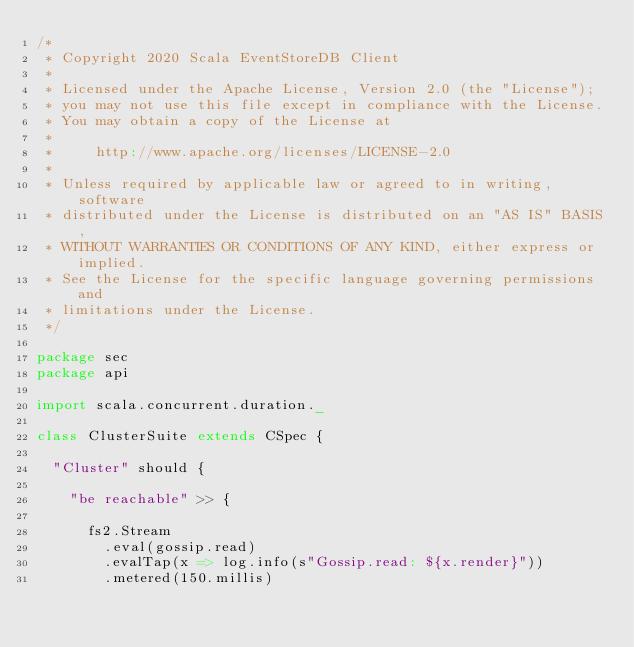Convert code to text. <code><loc_0><loc_0><loc_500><loc_500><_Scala_>/*
 * Copyright 2020 Scala EventStoreDB Client
 *
 * Licensed under the Apache License, Version 2.0 (the "License");
 * you may not use this file except in compliance with the License.
 * You may obtain a copy of the License at
 *
 *     http://www.apache.org/licenses/LICENSE-2.0
 *
 * Unless required by applicable law or agreed to in writing, software
 * distributed under the License is distributed on an "AS IS" BASIS,
 * WITHOUT WARRANTIES OR CONDITIONS OF ANY KIND, either express or implied.
 * See the License for the specific language governing permissions and
 * limitations under the License.
 */

package sec
package api

import scala.concurrent.duration._

class ClusterSuite extends CSpec {

  "Cluster" should {

    "be reachable" >> {

      fs2.Stream
        .eval(gossip.read)
        .evalTap(x => log.info(s"Gossip.read: ${x.render}"))
        .metered(150.millis)</code> 